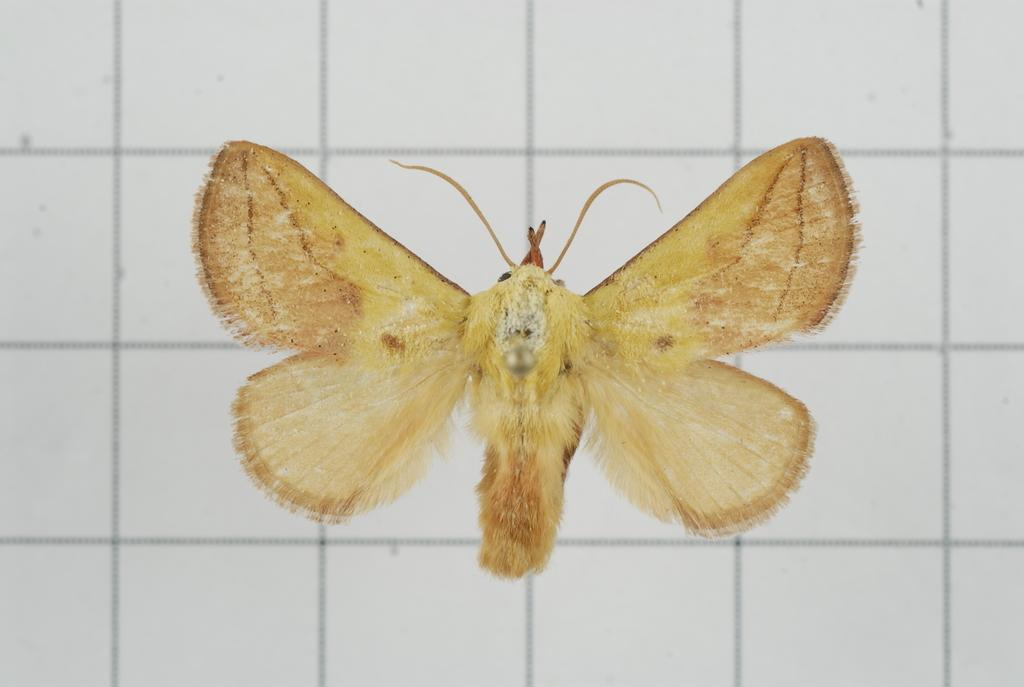What type of animal can be seen in the image? There is a butterfly in the image. What color is the background of the image? The background of the image is white. What type of ball is being smashed by the butterfly in the image? There is no ball present in the image, and the butterfly is not smashing anything. 